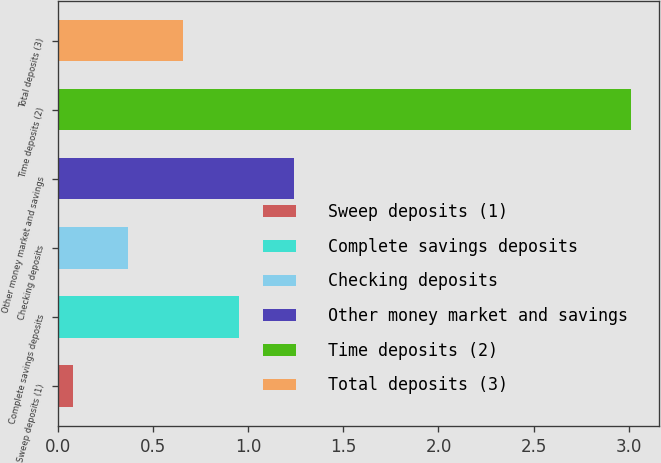Convert chart. <chart><loc_0><loc_0><loc_500><loc_500><bar_chart><fcel>Sweep deposits (1)<fcel>Complete savings deposits<fcel>Checking deposits<fcel>Other money market and savings<fcel>Time deposits (2)<fcel>Total deposits (3)<nl><fcel>0.08<fcel>0.95<fcel>0.37<fcel>1.24<fcel>3.01<fcel>0.66<nl></chart> 